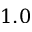Convert formula to latex. <formula><loc_0><loc_0><loc_500><loc_500>1 . 0</formula> 